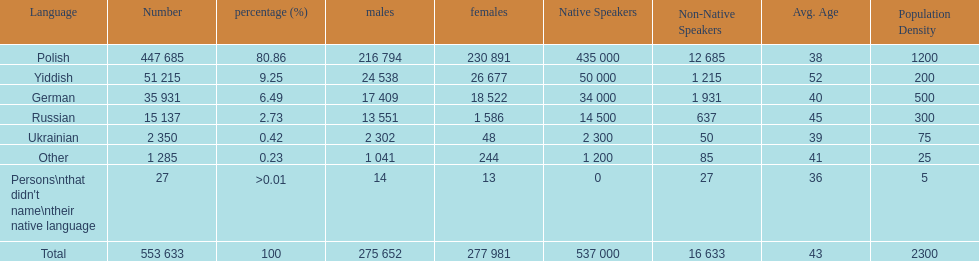Which language did the most people in the imperial census of 1897 speak in the p&#322;ock governorate? Polish. 